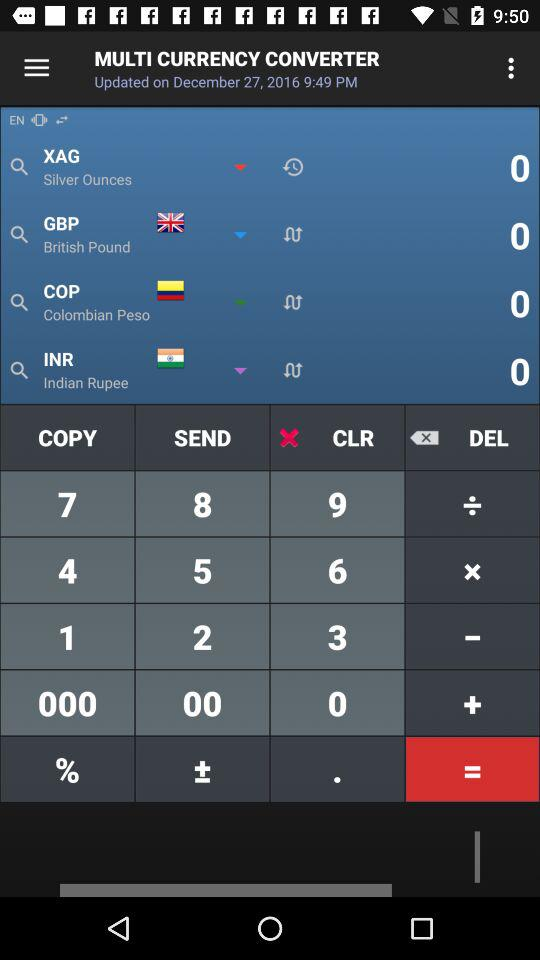What is the currency of Colombia? The currency of Colombia is the Colombian peso. 